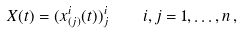<formula> <loc_0><loc_0><loc_500><loc_500>X ( t ) = ( x ^ { i } _ { ( j ) } ( t ) ) ^ { i } _ { j } \quad i , j = 1 , \dots , n \, ,</formula> 